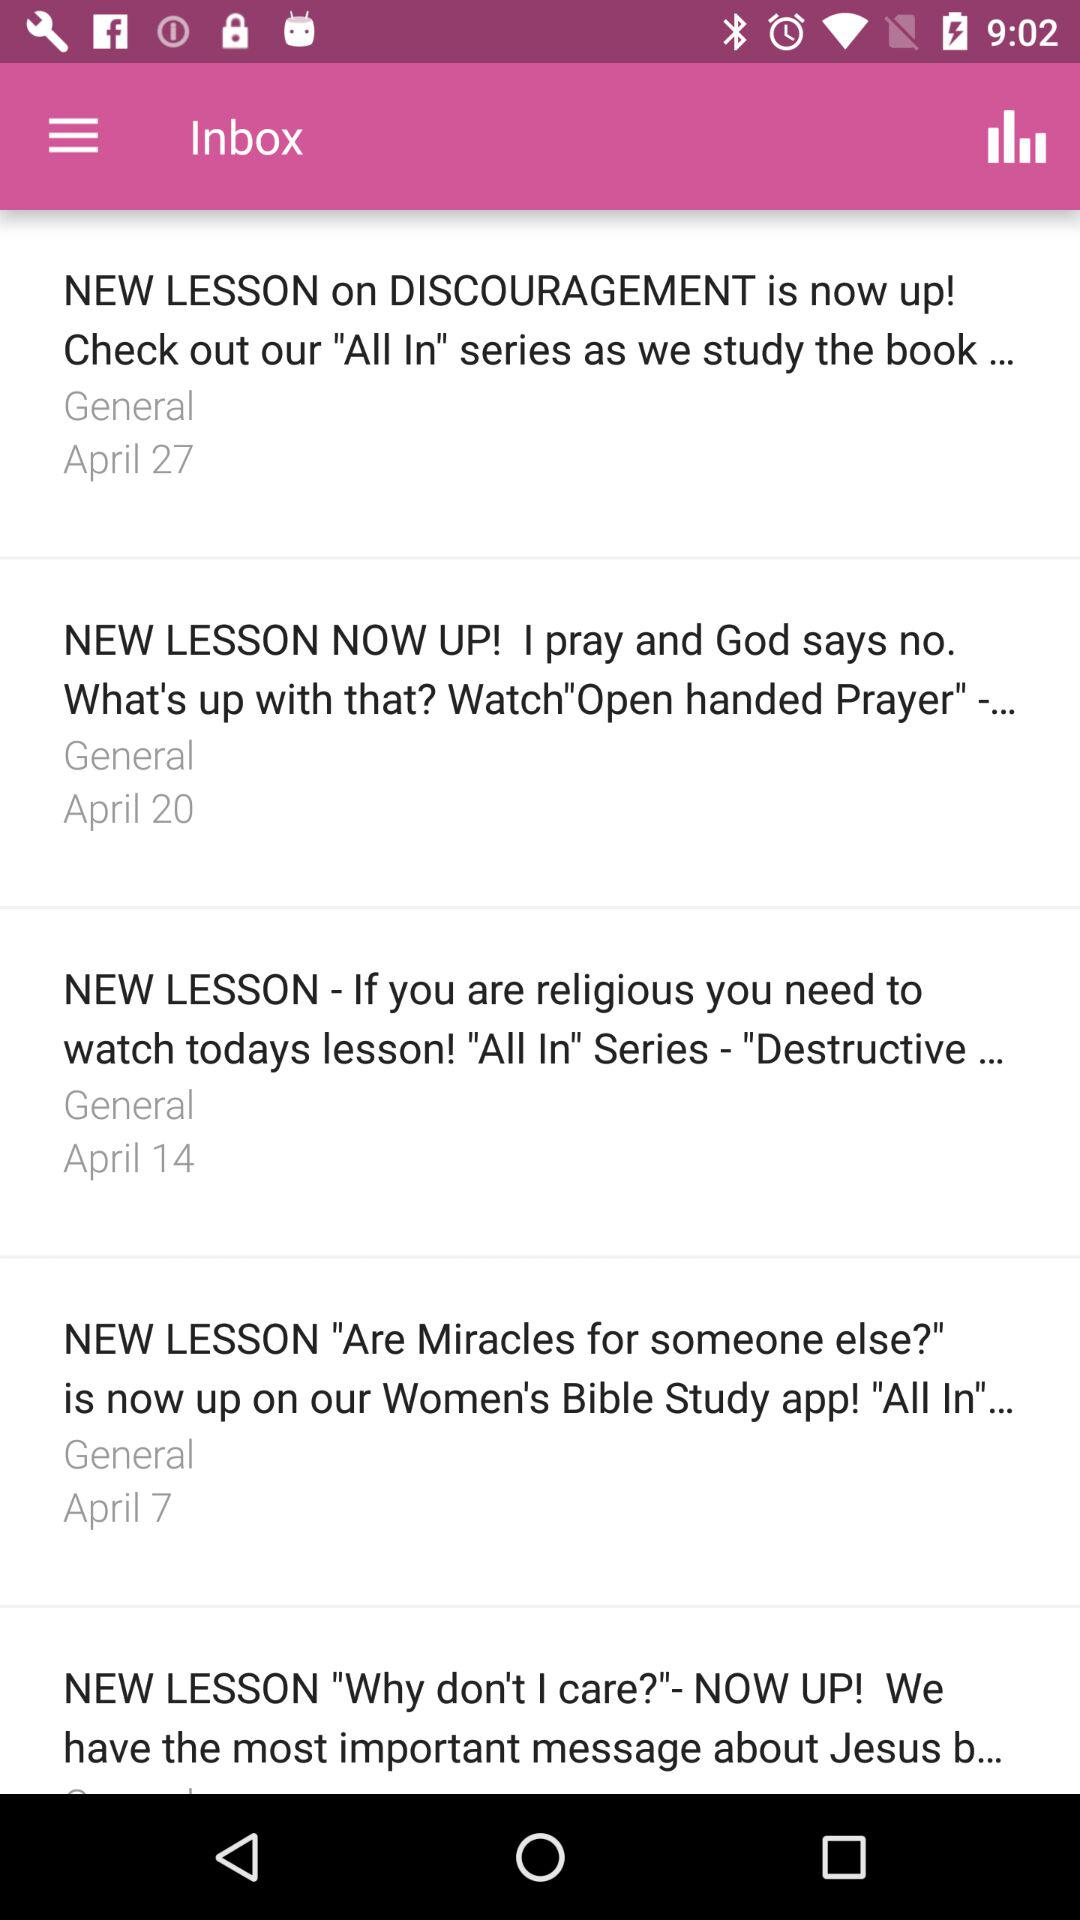On what date did the mail about the new lesson on "Are miracles for someone else?" arrive? The mail about the new lesson arrived on April 7. 